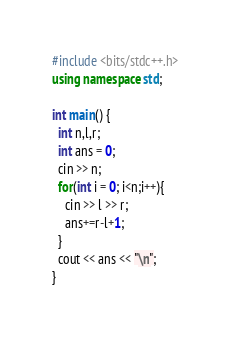<code> <loc_0><loc_0><loc_500><loc_500><_C++_>#include <bits/stdc++.h>
using namespace std;

int main() {
  int n,l,r;
  int ans = 0;
  cin >> n;
  for(int i = 0; i<n;i++){
    cin >> l >> r;
    ans+=r-l+1;
  }
  cout << ans << "\n";
}</code> 